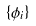<formula> <loc_0><loc_0><loc_500><loc_500>\{ \phi _ { i } \}</formula> 